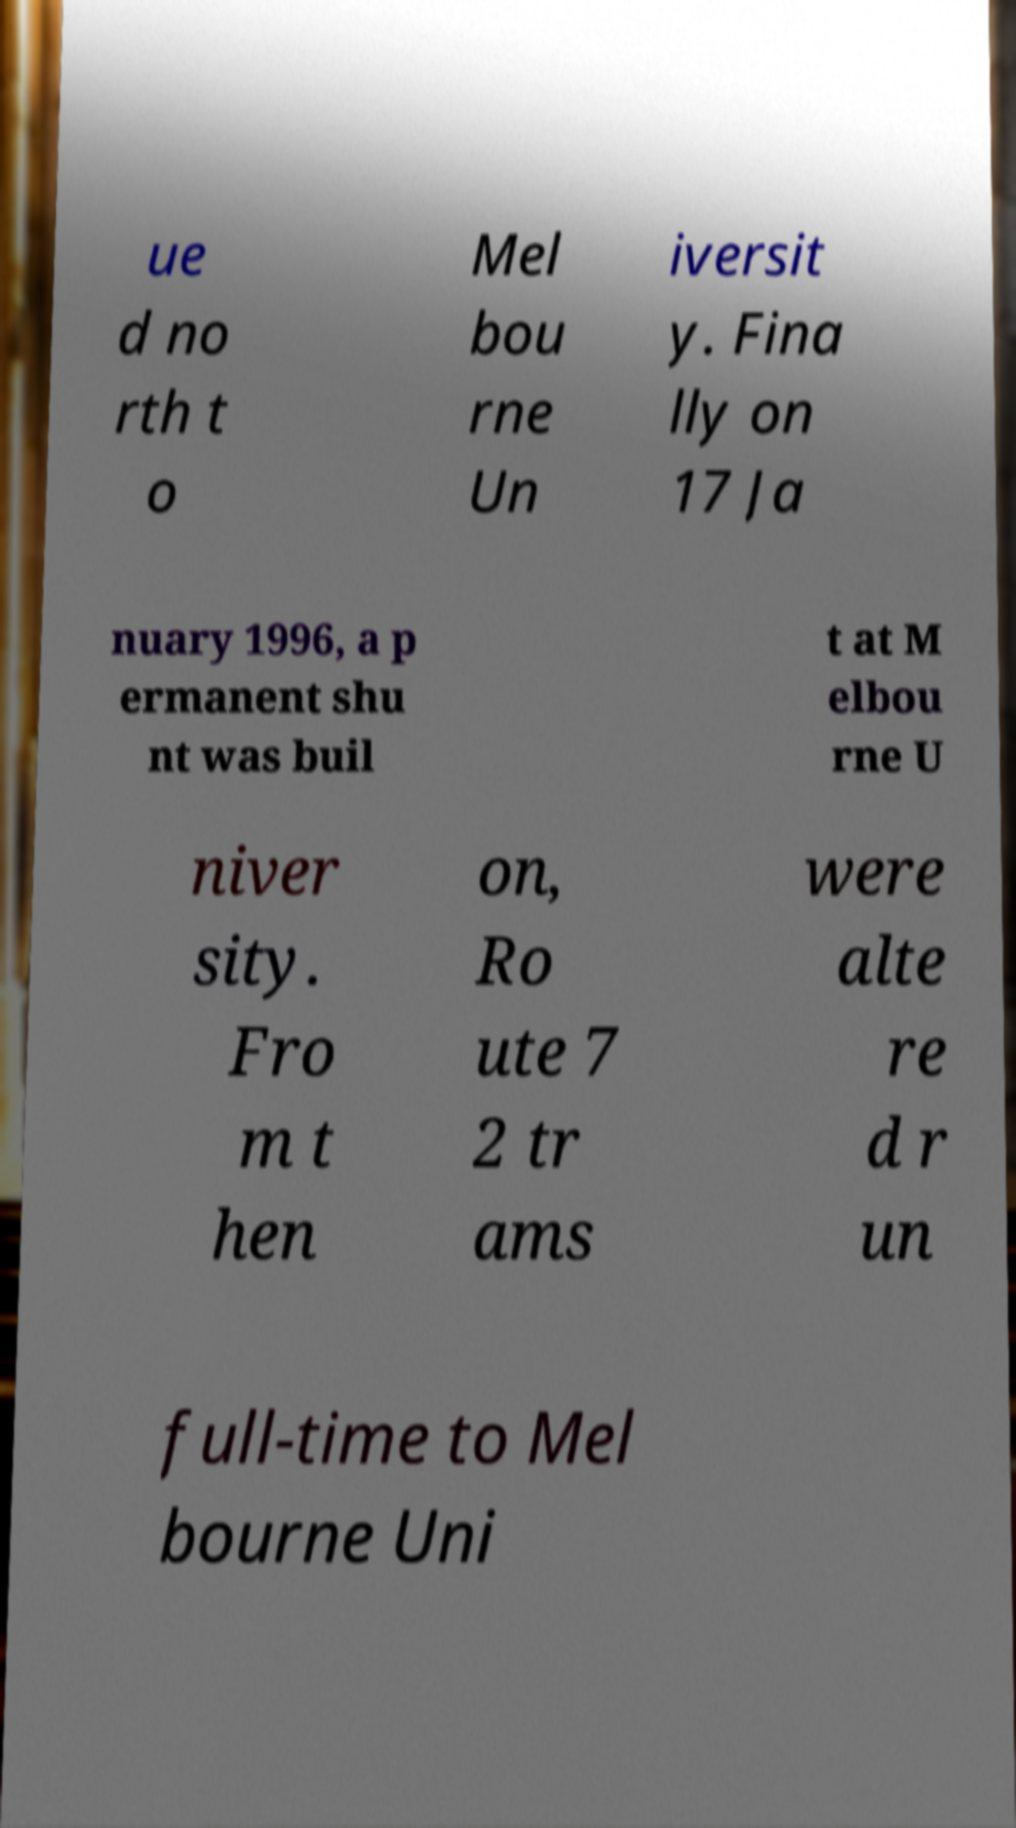What messages or text are displayed in this image? I need them in a readable, typed format. ue d no rth t o Mel bou rne Un iversit y. Fina lly on 17 Ja nuary 1996, a p ermanent shu nt was buil t at M elbou rne U niver sity. Fro m t hen on, Ro ute 7 2 tr ams were alte re d r un full-time to Mel bourne Uni 